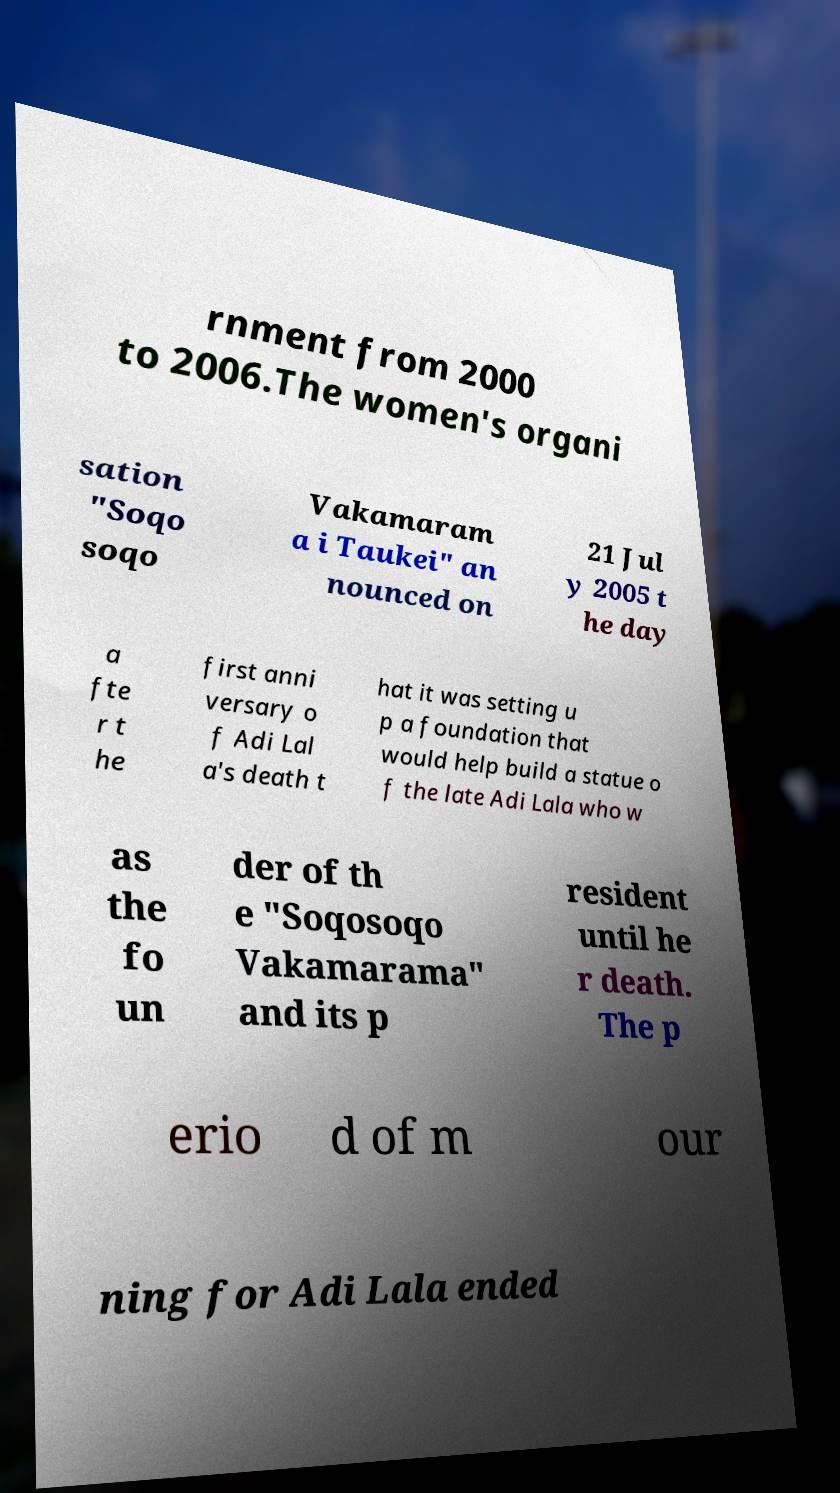Please identify and transcribe the text found in this image. rnment from 2000 to 2006.The women's organi sation "Soqo soqo Vakamaram a i Taukei" an nounced on 21 Jul y 2005 t he day a fte r t he first anni versary o f Adi Lal a's death t hat it was setting u p a foundation that would help build a statue o f the late Adi Lala who w as the fo un der of th e "Soqosoqo Vakamarama" and its p resident until he r death. The p erio d of m our ning for Adi Lala ended 